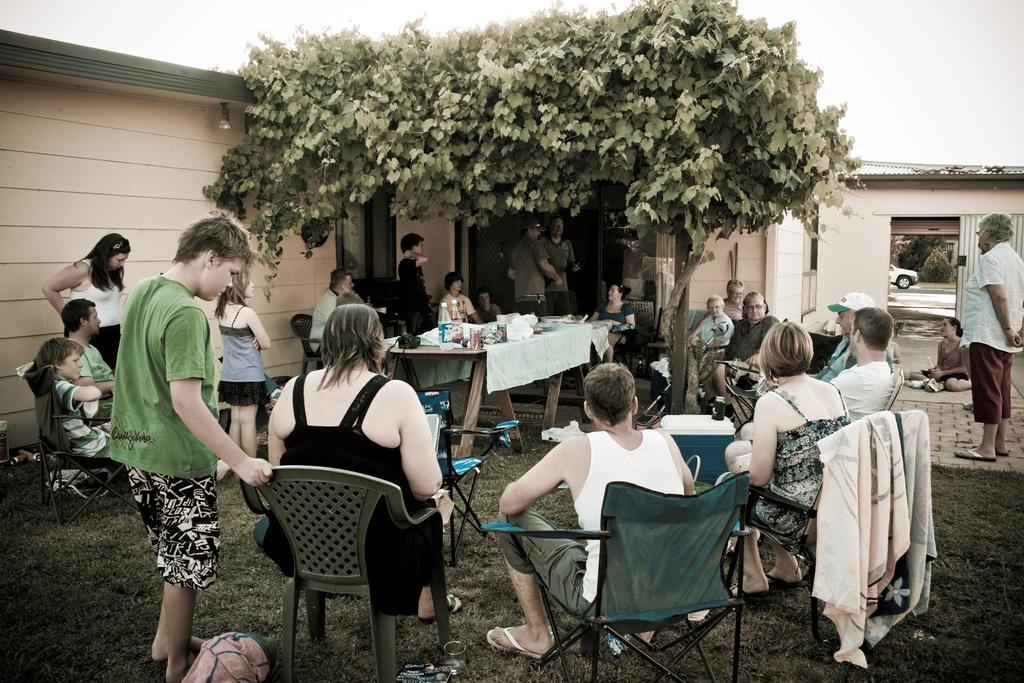How would you summarize this image in a sentence or two? This image is clicked outside. There is a tree on the top and building on the left side. There are so many people sitting outside on chairs. There is a table in the middle which has cloth on it and there are water bottles, boxes on this table. There is a car on the right side. 